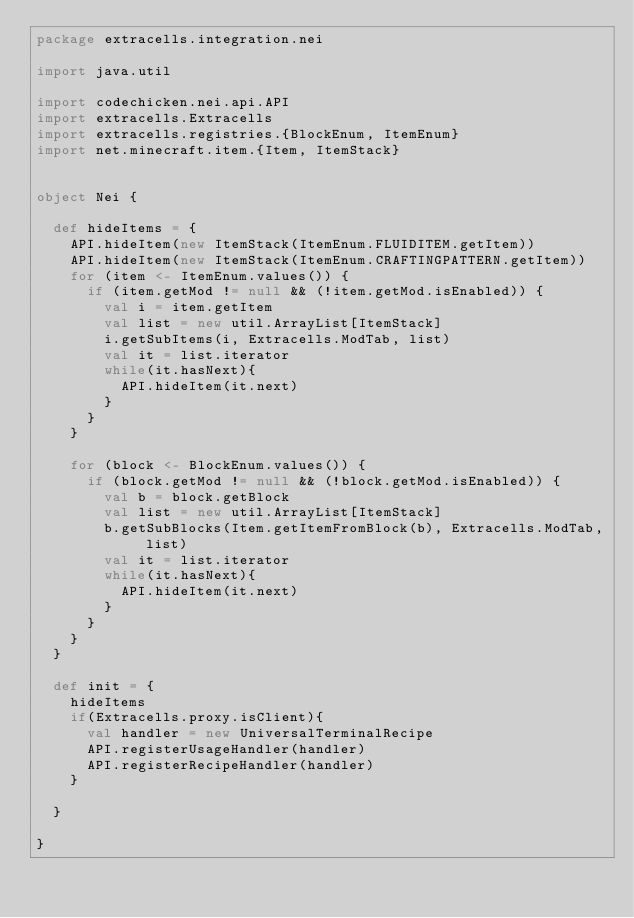<code> <loc_0><loc_0><loc_500><loc_500><_Scala_>package extracells.integration.nei

import java.util

import codechicken.nei.api.API
import extracells.Extracells
import extracells.registries.{BlockEnum, ItemEnum}
import net.minecraft.item.{Item, ItemStack}


object Nei {

  def hideItems = {
    API.hideItem(new ItemStack(ItemEnum.FLUIDITEM.getItem))
    API.hideItem(new ItemStack(ItemEnum.CRAFTINGPATTERN.getItem))
    for (item <- ItemEnum.values()) {
      if (item.getMod != null && (!item.getMod.isEnabled)) {
        val i = item.getItem
        val list = new util.ArrayList[ItemStack]
        i.getSubItems(i, Extracells.ModTab, list)
        val it = list.iterator
        while(it.hasNext){
          API.hideItem(it.next)
        }
      }
    }

    for (block <- BlockEnum.values()) {
      if (block.getMod != null && (!block.getMod.isEnabled)) {
        val b = block.getBlock
        val list = new util.ArrayList[ItemStack]
        b.getSubBlocks(Item.getItemFromBlock(b), Extracells.ModTab, list)
        val it = list.iterator
        while(it.hasNext){
          API.hideItem(it.next)
        }
      }
    }
  }

  def init = {
    hideItems
    if(Extracells.proxy.isClient){
      val handler = new UniversalTerminalRecipe
      API.registerUsageHandler(handler)
      API.registerRecipeHandler(handler)
    }

  }

}
</code> 